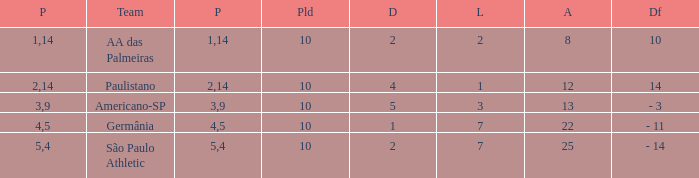What is the lowest Against when the played is more than 10? None. 